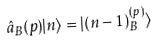Convert formula to latex. <formula><loc_0><loc_0><loc_500><loc_500>\hat { a } _ { B } ( p ) | n \rangle = | ( n - 1 ) _ { B } ^ { ( p ) } \rangle</formula> 